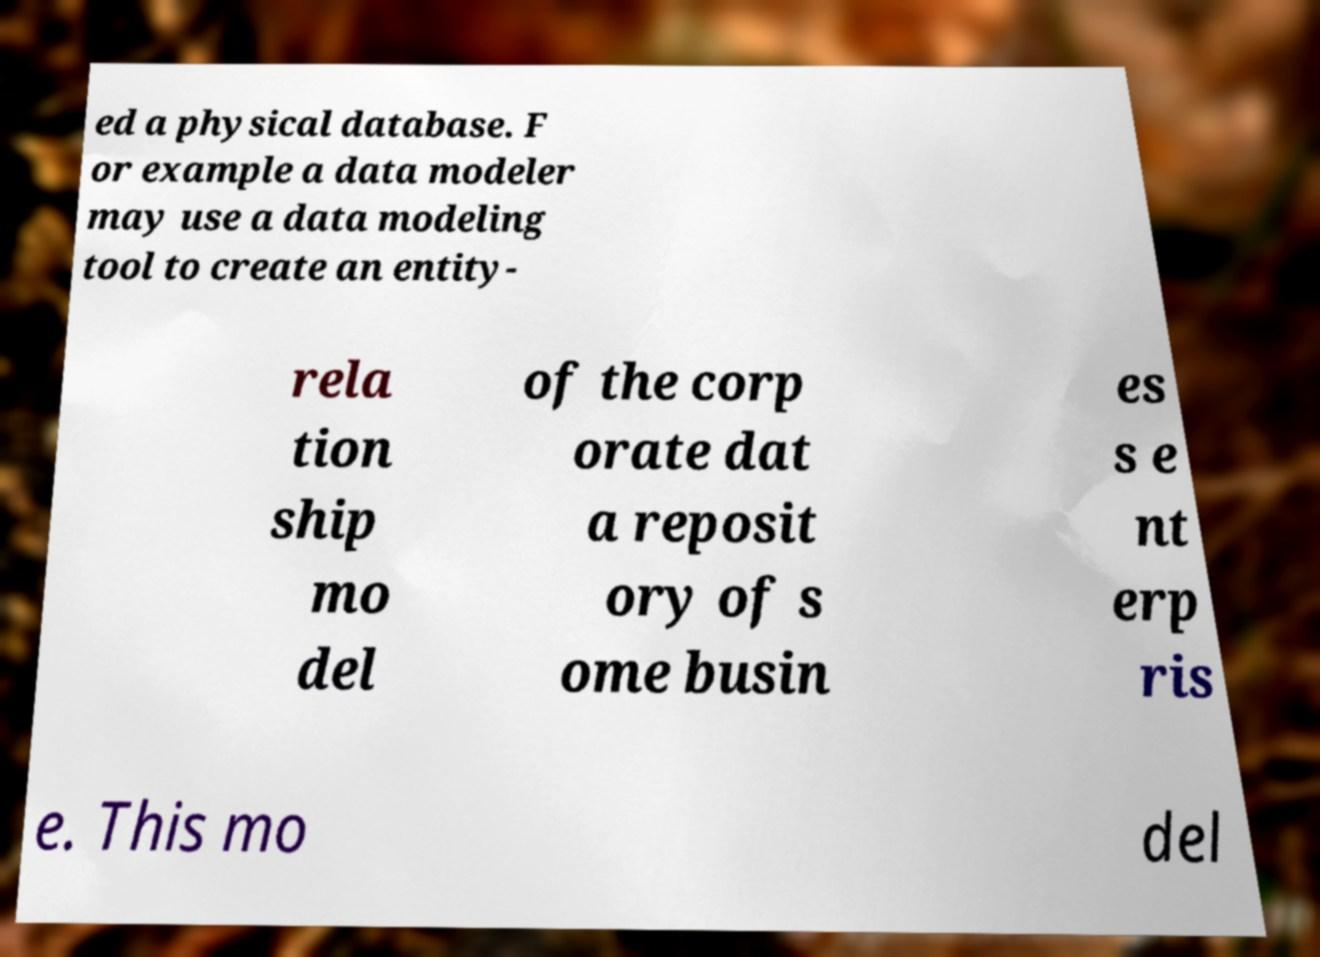Can you read and provide the text displayed in the image?This photo seems to have some interesting text. Can you extract and type it out for me? ed a physical database. F or example a data modeler may use a data modeling tool to create an entity- rela tion ship mo del of the corp orate dat a reposit ory of s ome busin es s e nt erp ris e. This mo del 